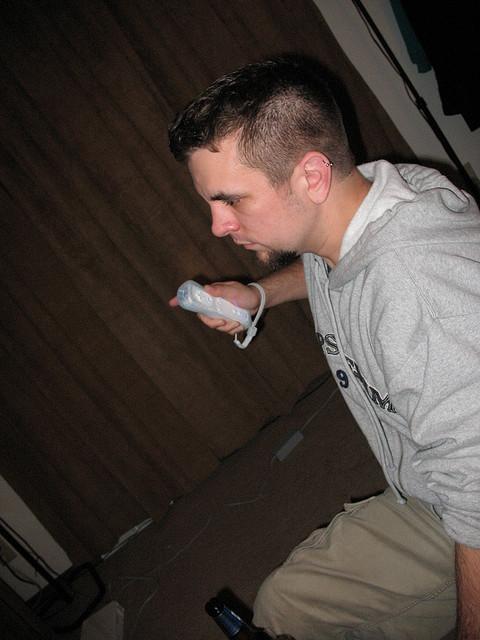How many umbrellas do you see?
Give a very brief answer. 0. 